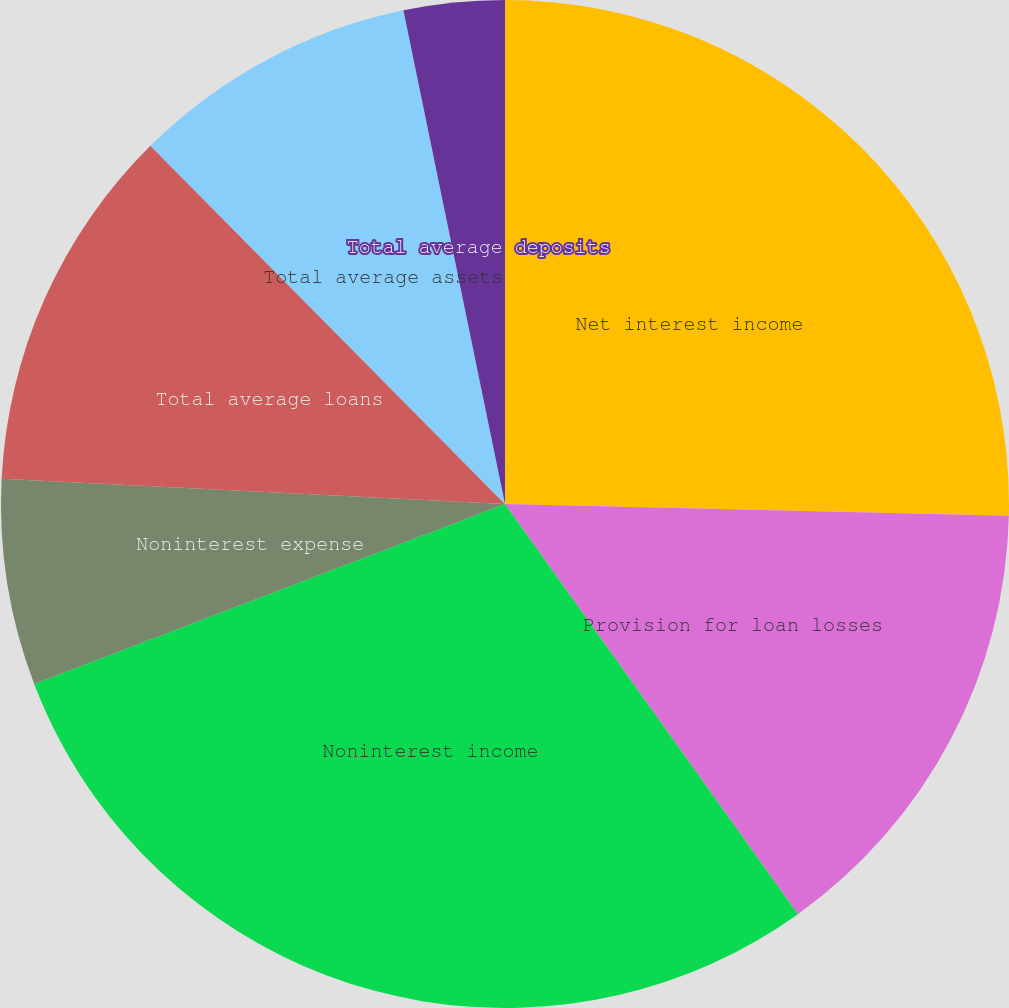<chart> <loc_0><loc_0><loc_500><loc_500><pie_chart><fcel>Net interest income<fcel>Provision for loan losses<fcel>Noninterest income<fcel>Noninterest expense<fcel>Total average loans<fcel>Total average assets<fcel>Total average deposits<nl><fcel>25.37%<fcel>14.76%<fcel>29.06%<fcel>6.61%<fcel>11.78%<fcel>9.19%<fcel>3.23%<nl></chart> 